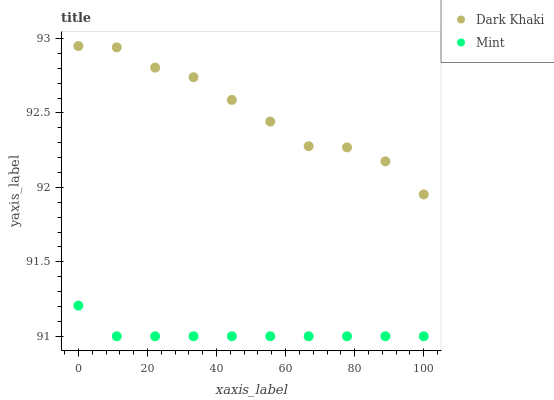Does Mint have the minimum area under the curve?
Answer yes or no. Yes. Does Dark Khaki have the maximum area under the curve?
Answer yes or no. Yes. Does Mint have the maximum area under the curve?
Answer yes or no. No. Is Mint the smoothest?
Answer yes or no. Yes. Is Dark Khaki the roughest?
Answer yes or no. Yes. Is Mint the roughest?
Answer yes or no. No. Does Mint have the lowest value?
Answer yes or no. Yes. Does Dark Khaki have the highest value?
Answer yes or no. Yes. Does Mint have the highest value?
Answer yes or no. No. Is Mint less than Dark Khaki?
Answer yes or no. Yes. Is Dark Khaki greater than Mint?
Answer yes or no. Yes. Does Mint intersect Dark Khaki?
Answer yes or no. No. 